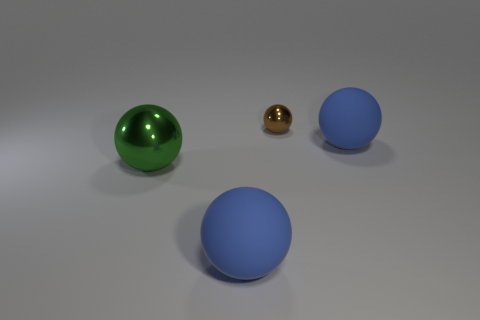Are there any other things that have the same size as the brown thing?
Your response must be concise. No. Do the brown metallic ball and the blue matte object that is right of the tiny brown ball have the same size?
Your answer should be compact. No. What color is the other metal object that is the same shape as the green metal object?
Keep it short and to the point. Brown. What number of big rubber spheres are on the right side of the big blue thing that is to the right of the brown metal object?
Provide a short and direct response. 0. What number of cubes are small objects or yellow things?
Your answer should be very brief. 0. Are any tiny shiny balls visible?
Keep it short and to the point. Yes. What size is the brown metallic thing that is the same shape as the big green metal object?
Ensure brevity in your answer.  Small. What is the shape of the metallic object that is in front of the big sphere that is on the right side of the tiny brown object?
Keep it short and to the point. Sphere. How many purple things are matte objects or shiny blocks?
Provide a short and direct response. 0. The tiny metal sphere is what color?
Provide a short and direct response. Brown. 